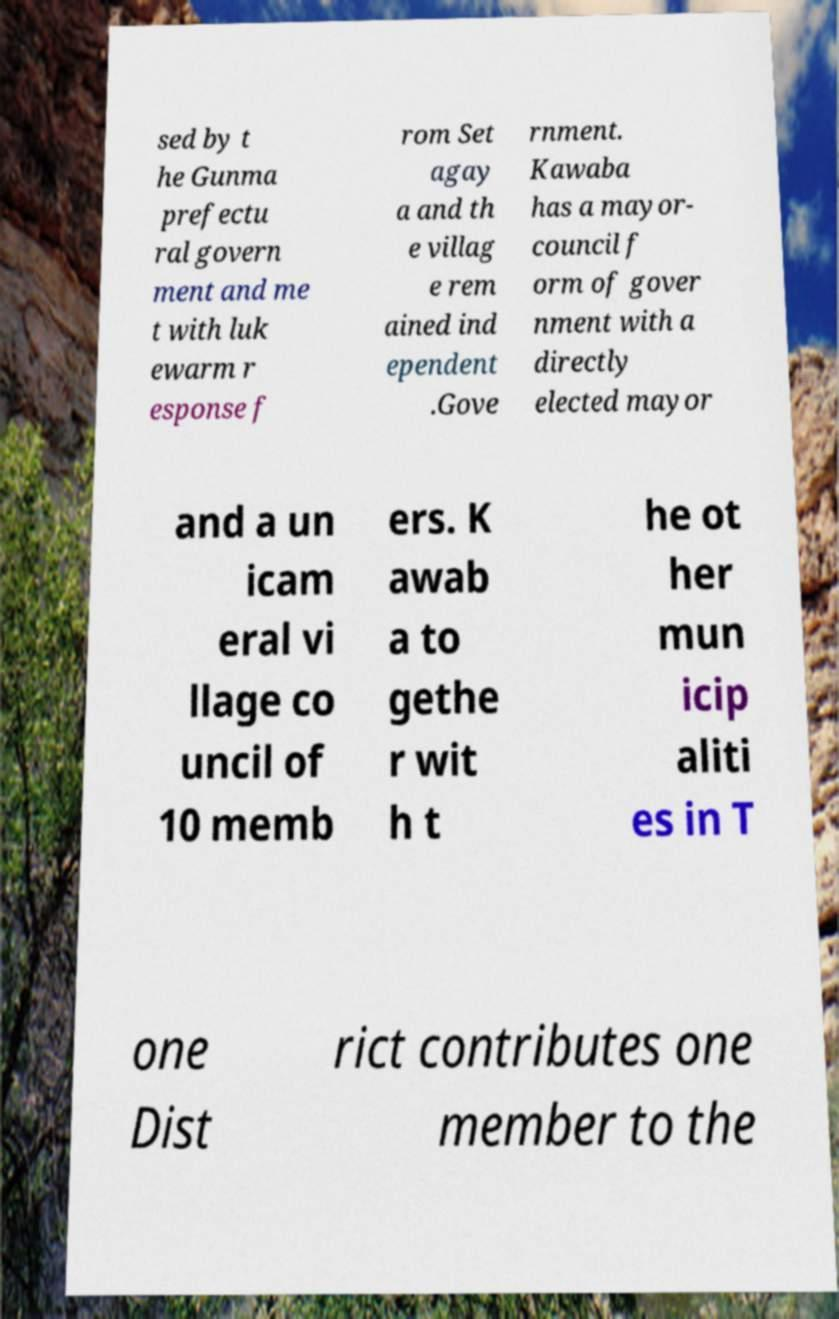I need the written content from this picture converted into text. Can you do that? sed by t he Gunma prefectu ral govern ment and me t with luk ewarm r esponse f rom Set agay a and th e villag e rem ained ind ependent .Gove rnment. Kawaba has a mayor- council f orm of gover nment with a directly elected mayor and a un icam eral vi llage co uncil of 10 memb ers. K awab a to gethe r wit h t he ot her mun icip aliti es in T one Dist rict contributes one member to the 